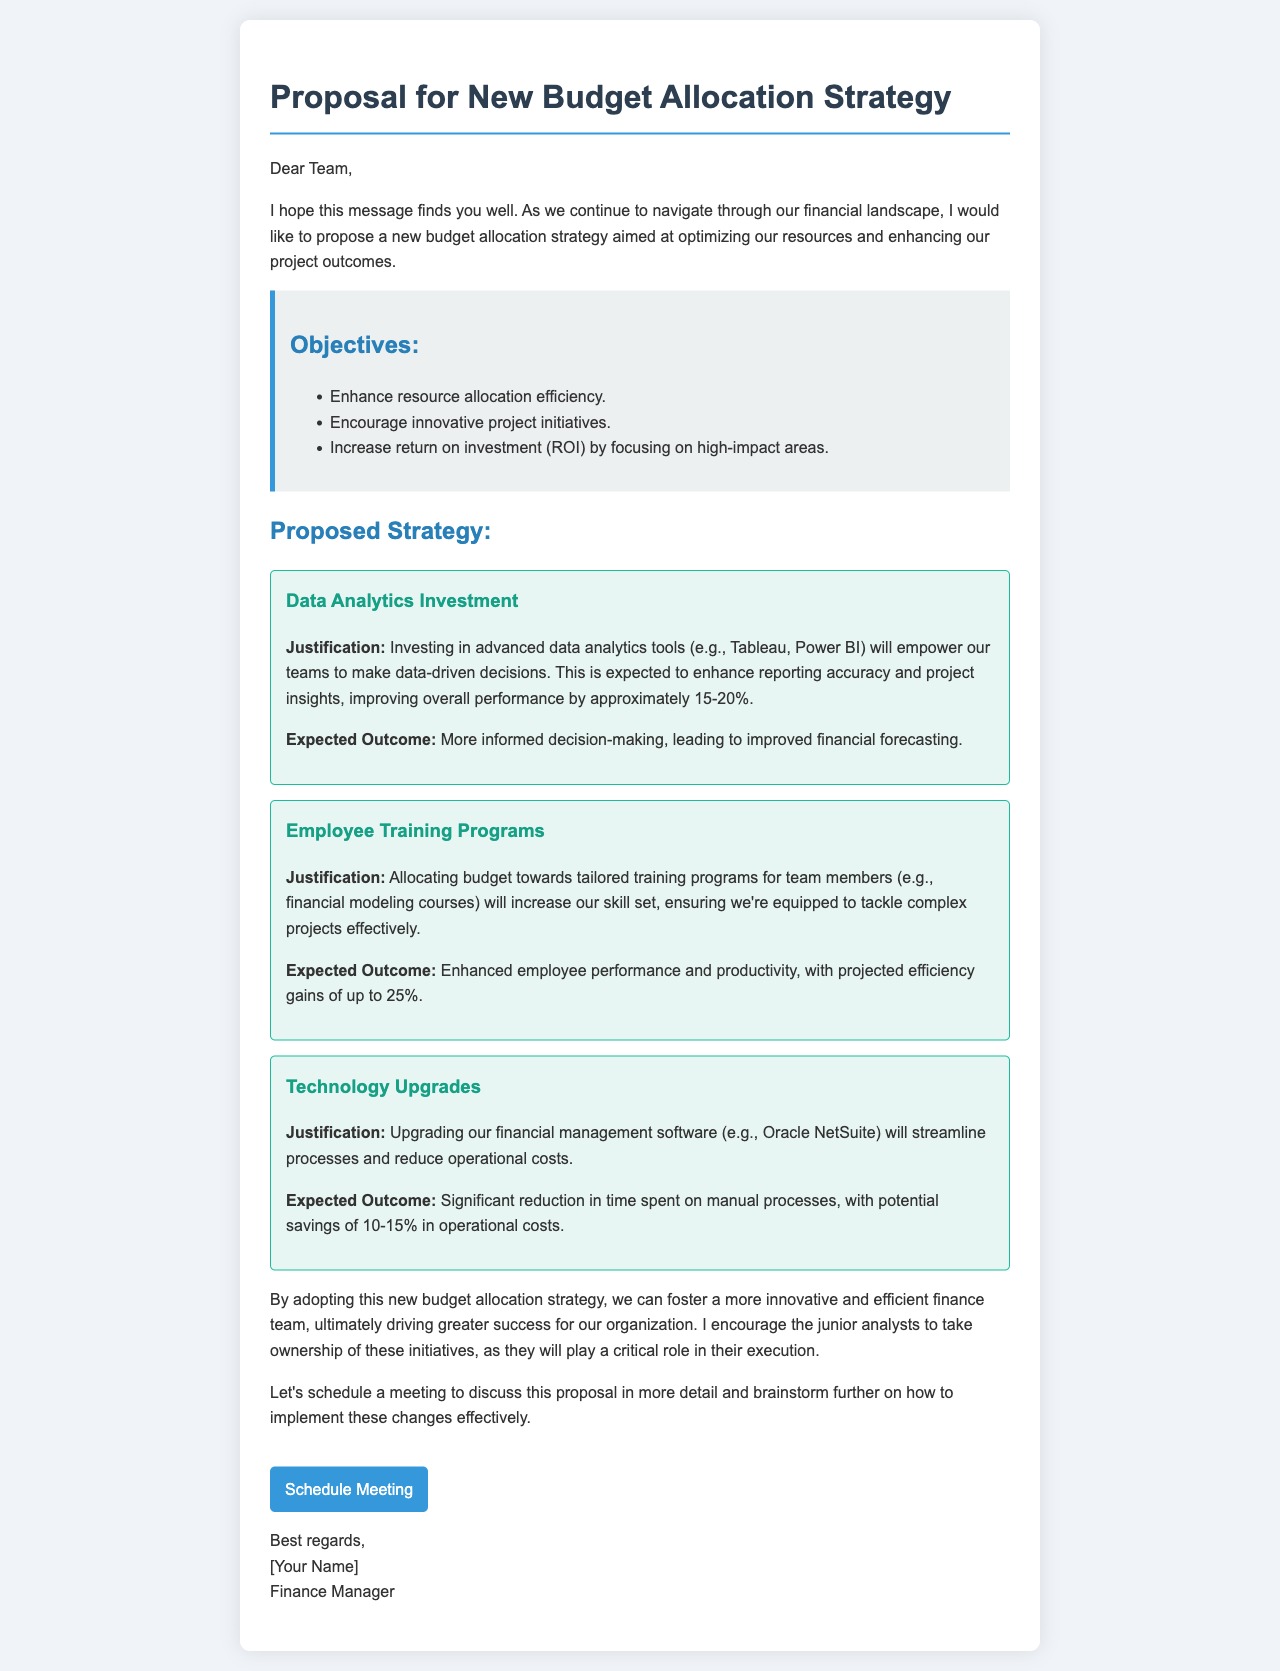what is the main proposal topic? The main proposal topic is centered around budget allocation strategy aimed at enhancing resource allocation and project outcomes.
Answer: New Budget Allocation Strategy what is one of the objectives listed in the document? The document lists several objectives, including enhancing resource allocation efficiency.
Answer: Enhance resource allocation efficiency how much is the expected improvement in overall performance from data analytics investment? The proposal states that investing in data analytics tools is expected to improve overall performance by approximately 15-20%.
Answer: 15-20% what training is proposed for employee development? The document proposes tailored training programs, specifically mentioning financial modeling courses.
Answer: Financial modeling courses what is one expected outcome of upgrading the financial management software? Upgrading the financial management software is expected to result in significant reduction in time spent on manual processes.
Answer: Significant reduction in time spent on manual processes why should junior analysts take ownership of the initiatives? The document encourages junior analysts to take ownership because they will play a critical role in the execution of the initiatives.
Answer: Critical role in execution what technology is mentioned for potential upgrades? The proposal mentions upgrading Oracle NetSuite as the financial management software.
Answer: Oracle NetSuite how much efficiency gain is projected from employee training programs? The expected efficiency gains from employee training programs are projected to be up to 25%.
Answer: Up to 25% 